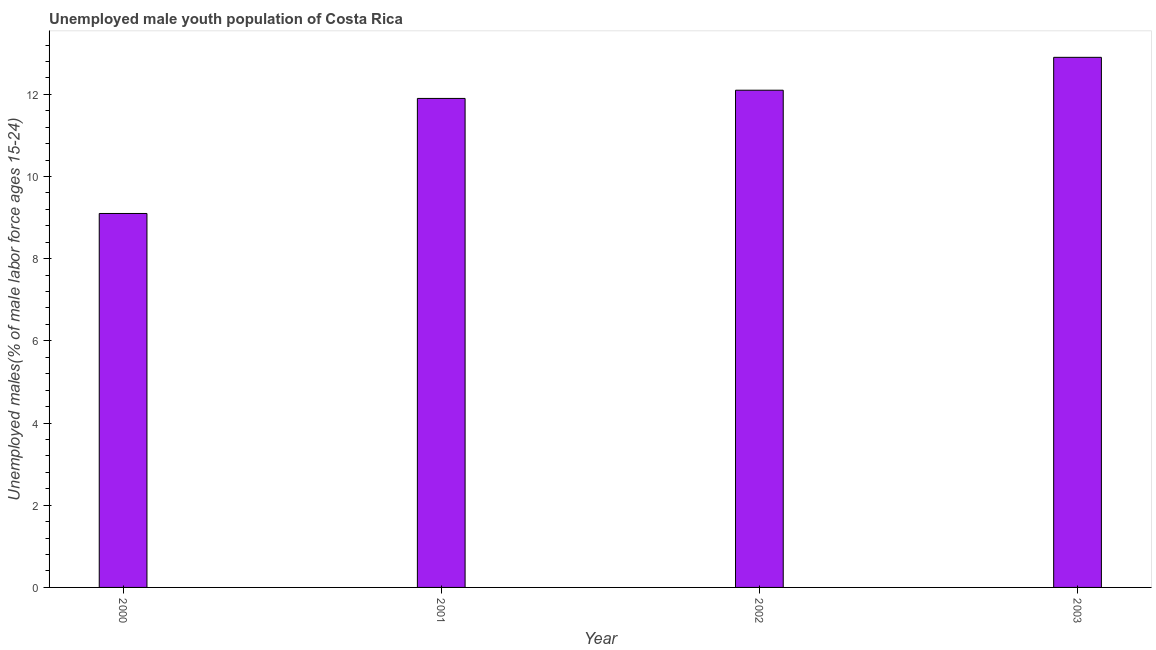Does the graph contain any zero values?
Offer a terse response. No. Does the graph contain grids?
Your answer should be very brief. No. What is the title of the graph?
Offer a terse response. Unemployed male youth population of Costa Rica. What is the label or title of the X-axis?
Provide a succinct answer. Year. What is the label or title of the Y-axis?
Give a very brief answer. Unemployed males(% of male labor force ages 15-24). What is the unemployed male youth in 2003?
Your response must be concise. 12.9. Across all years, what is the maximum unemployed male youth?
Provide a short and direct response. 12.9. Across all years, what is the minimum unemployed male youth?
Give a very brief answer. 9.1. In which year was the unemployed male youth maximum?
Provide a short and direct response. 2003. In which year was the unemployed male youth minimum?
Your answer should be compact. 2000. What is the sum of the unemployed male youth?
Ensure brevity in your answer.  46. What is the difference between the unemployed male youth in 2002 and 2003?
Provide a short and direct response. -0.8. What is the ratio of the unemployed male youth in 2001 to that in 2002?
Ensure brevity in your answer.  0.98. Is the unemployed male youth in 2000 less than that in 2003?
Give a very brief answer. Yes. What is the difference between the highest and the second highest unemployed male youth?
Provide a succinct answer. 0.8. How many years are there in the graph?
Your answer should be very brief. 4. What is the difference between two consecutive major ticks on the Y-axis?
Keep it short and to the point. 2. What is the Unemployed males(% of male labor force ages 15-24) in 2000?
Make the answer very short. 9.1. What is the Unemployed males(% of male labor force ages 15-24) of 2001?
Give a very brief answer. 11.9. What is the Unemployed males(% of male labor force ages 15-24) of 2002?
Your answer should be very brief. 12.1. What is the Unemployed males(% of male labor force ages 15-24) of 2003?
Offer a terse response. 12.9. What is the difference between the Unemployed males(% of male labor force ages 15-24) in 2000 and 2001?
Your response must be concise. -2.8. What is the difference between the Unemployed males(% of male labor force ages 15-24) in 2000 and 2002?
Make the answer very short. -3. What is the difference between the Unemployed males(% of male labor force ages 15-24) in 2001 and 2003?
Your response must be concise. -1. What is the difference between the Unemployed males(% of male labor force ages 15-24) in 2002 and 2003?
Make the answer very short. -0.8. What is the ratio of the Unemployed males(% of male labor force ages 15-24) in 2000 to that in 2001?
Provide a succinct answer. 0.77. What is the ratio of the Unemployed males(% of male labor force ages 15-24) in 2000 to that in 2002?
Make the answer very short. 0.75. What is the ratio of the Unemployed males(% of male labor force ages 15-24) in 2000 to that in 2003?
Offer a terse response. 0.7. What is the ratio of the Unemployed males(% of male labor force ages 15-24) in 2001 to that in 2003?
Your response must be concise. 0.92. What is the ratio of the Unemployed males(% of male labor force ages 15-24) in 2002 to that in 2003?
Your answer should be very brief. 0.94. 